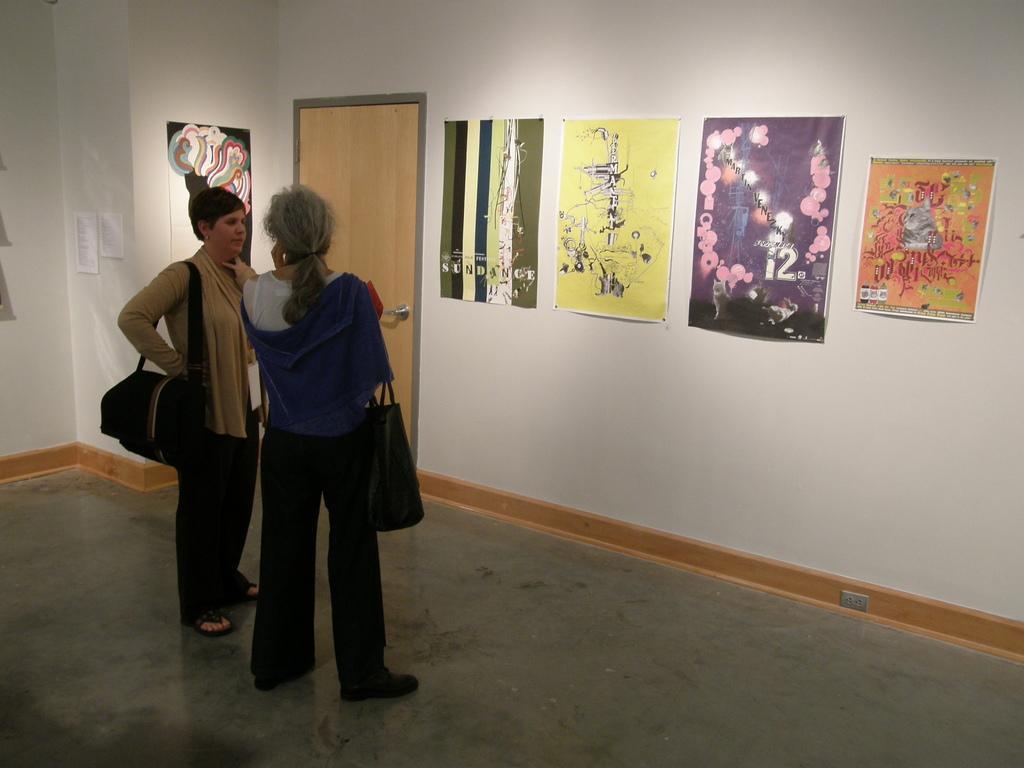In one or two sentences, can you explain what this image depicts? In this image we can see two people standing and wearing handbags, in front of the there are few posters and a door to the wall. 